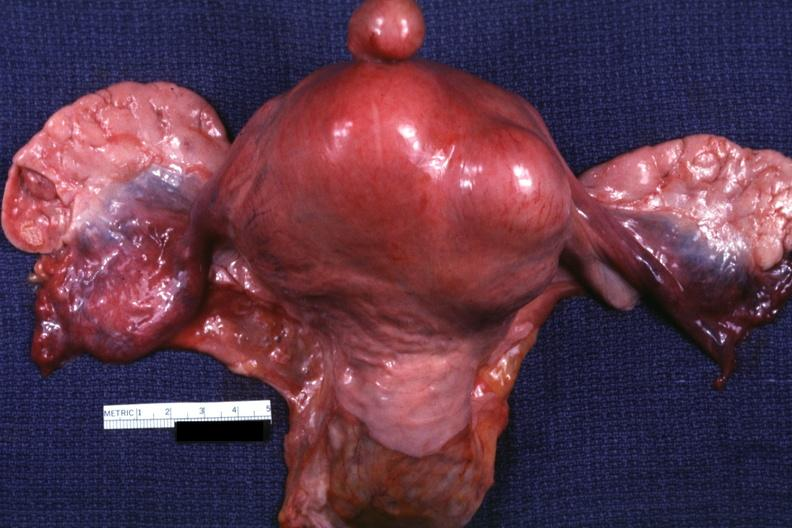s hand present?
Answer the question using a single word or phrase. No 